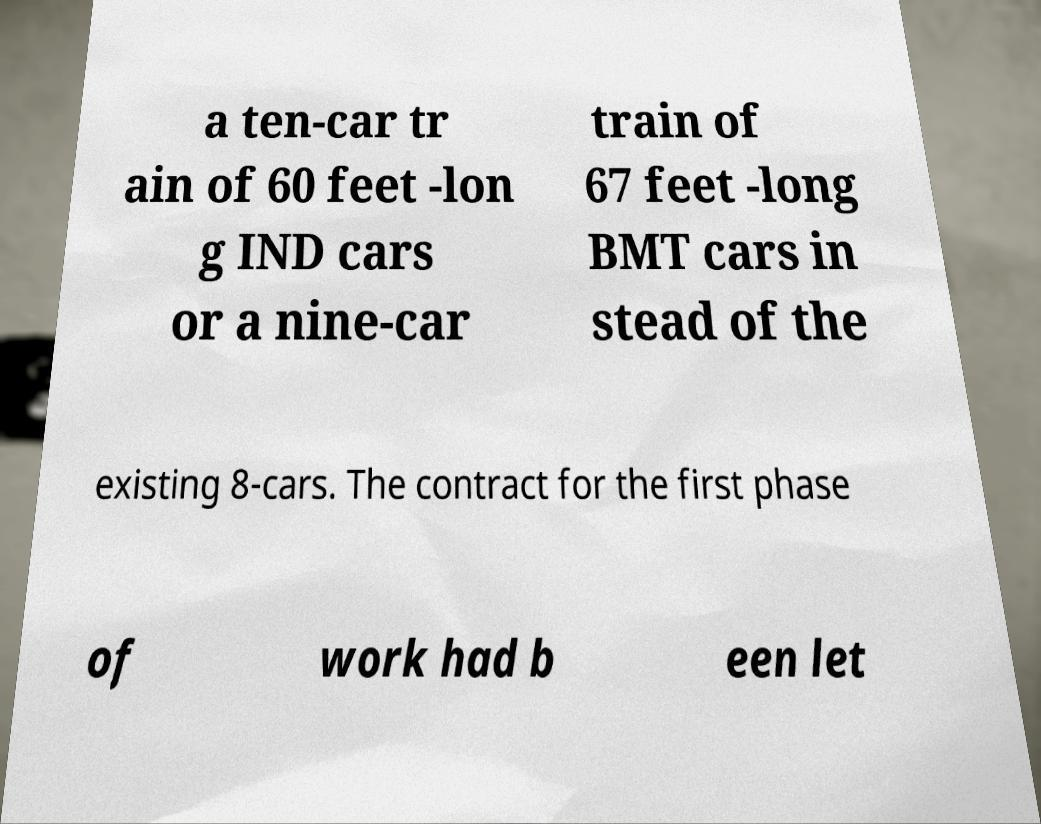There's text embedded in this image that I need extracted. Can you transcribe it verbatim? a ten-car tr ain of 60 feet -lon g IND cars or a nine-car train of 67 feet -long BMT cars in stead of the existing 8-cars. The contract for the first phase of work had b een let 